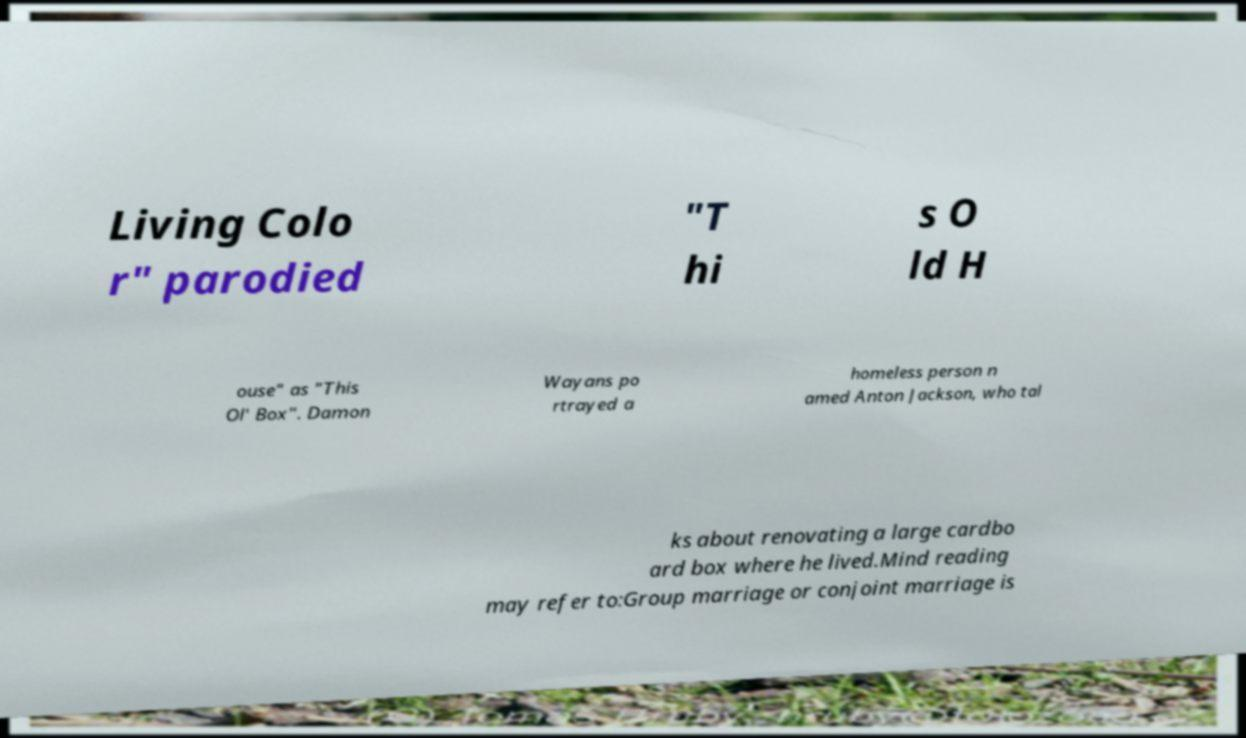Could you extract and type out the text from this image? Living Colo r" parodied "T hi s O ld H ouse" as "This Ol' Box". Damon Wayans po rtrayed a homeless person n amed Anton Jackson, who tal ks about renovating a large cardbo ard box where he lived.Mind reading may refer to:Group marriage or conjoint marriage is 